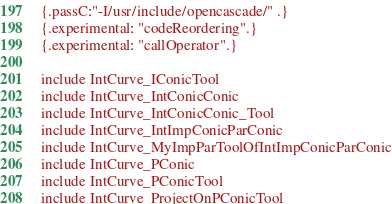<code> <loc_0><loc_0><loc_500><loc_500><_Nim_>{.passC:"-I/usr/include/opencascade/" .}
{.experimental: "codeReordering".}
{.experimental: "callOperator".}

include IntCurve_IConicTool
include IntCurve_IntConicConic
include IntCurve_IntConicConic_Tool
include IntCurve_IntImpConicParConic
include IntCurve_MyImpParToolOfIntImpConicParConic
include IntCurve_PConic
include IntCurve_PConicTool
include IntCurve_ProjectOnPConicTool


























</code> 